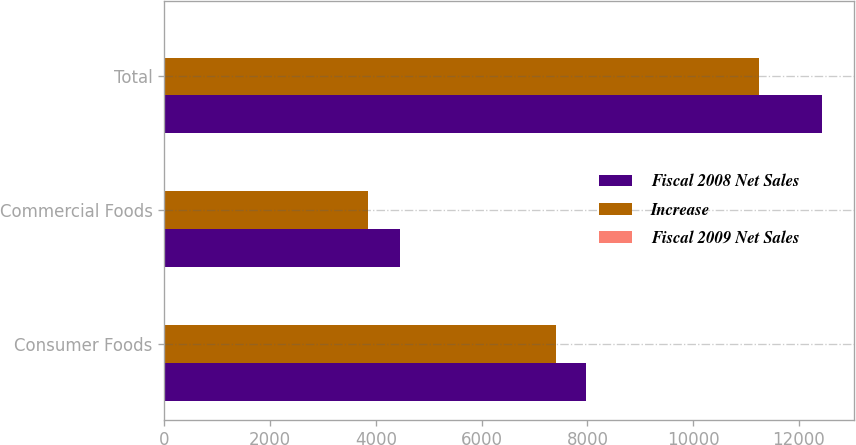<chart> <loc_0><loc_0><loc_500><loc_500><stacked_bar_chart><ecel><fcel>Consumer Foods<fcel>Commercial Foods<fcel>Total<nl><fcel>Fiscal 2008 Net Sales<fcel>7979<fcel>4447<fcel>12426<nl><fcel>Increase<fcel>7400<fcel>3848<fcel>11248<nl><fcel>Fiscal 2009 Net Sales<fcel>8<fcel>16<fcel>11<nl></chart> 